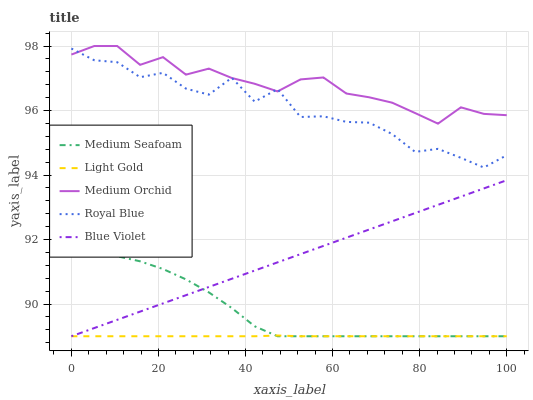Does Light Gold have the minimum area under the curve?
Answer yes or no. Yes. Does Medium Orchid have the maximum area under the curve?
Answer yes or no. Yes. Does Medium Orchid have the minimum area under the curve?
Answer yes or no. No. Does Light Gold have the maximum area under the curve?
Answer yes or no. No. Is Blue Violet the smoothest?
Answer yes or no. Yes. Is Royal Blue the roughest?
Answer yes or no. Yes. Is Medium Orchid the smoothest?
Answer yes or no. No. Is Medium Orchid the roughest?
Answer yes or no. No. Does Light Gold have the lowest value?
Answer yes or no. Yes. Does Medium Orchid have the lowest value?
Answer yes or no. No. Does Medium Orchid have the highest value?
Answer yes or no. Yes. Does Light Gold have the highest value?
Answer yes or no. No. Is Medium Seafoam less than Medium Orchid?
Answer yes or no. Yes. Is Medium Orchid greater than Blue Violet?
Answer yes or no. Yes. Does Light Gold intersect Medium Seafoam?
Answer yes or no. Yes. Is Light Gold less than Medium Seafoam?
Answer yes or no. No. Is Light Gold greater than Medium Seafoam?
Answer yes or no. No. Does Medium Seafoam intersect Medium Orchid?
Answer yes or no. No. 